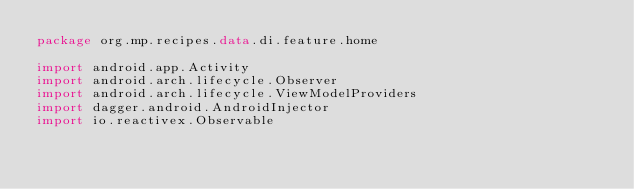<code> <loc_0><loc_0><loc_500><loc_500><_Kotlin_>package org.mp.recipes.data.di.feature.home

import android.app.Activity
import android.arch.lifecycle.Observer
import android.arch.lifecycle.ViewModelProviders
import dagger.android.AndroidInjector
import io.reactivex.Observable</code> 